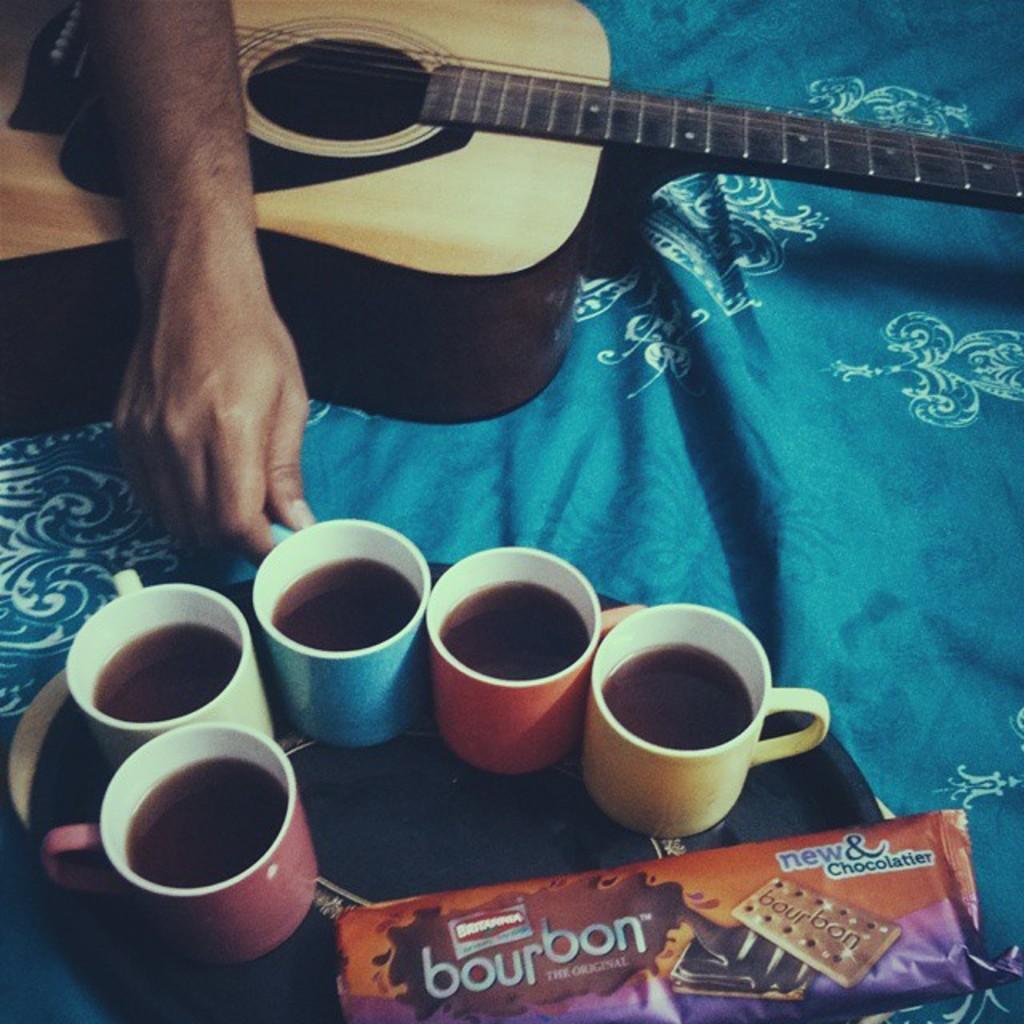Please provide a concise description of this image. In this picture we can see few cups with coffee and there is a biscuit packet on the tray. This is guitar. A person holding a cup. This is cloth. 